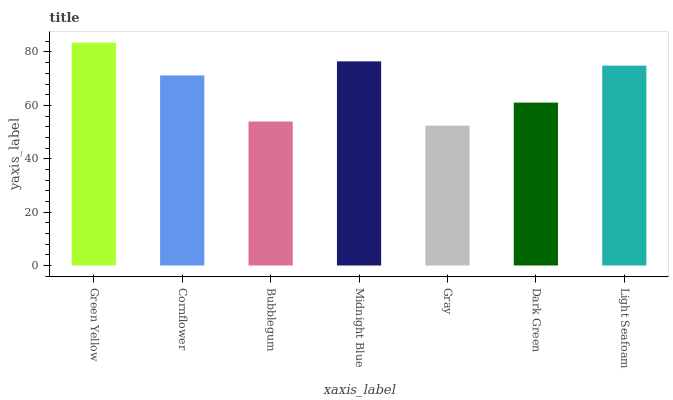Is Gray the minimum?
Answer yes or no. Yes. Is Green Yellow the maximum?
Answer yes or no. Yes. Is Cornflower the minimum?
Answer yes or no. No. Is Cornflower the maximum?
Answer yes or no. No. Is Green Yellow greater than Cornflower?
Answer yes or no. Yes. Is Cornflower less than Green Yellow?
Answer yes or no. Yes. Is Cornflower greater than Green Yellow?
Answer yes or no. No. Is Green Yellow less than Cornflower?
Answer yes or no. No. Is Cornflower the high median?
Answer yes or no. Yes. Is Cornflower the low median?
Answer yes or no. Yes. Is Bubblegum the high median?
Answer yes or no. No. Is Dark Green the low median?
Answer yes or no. No. 